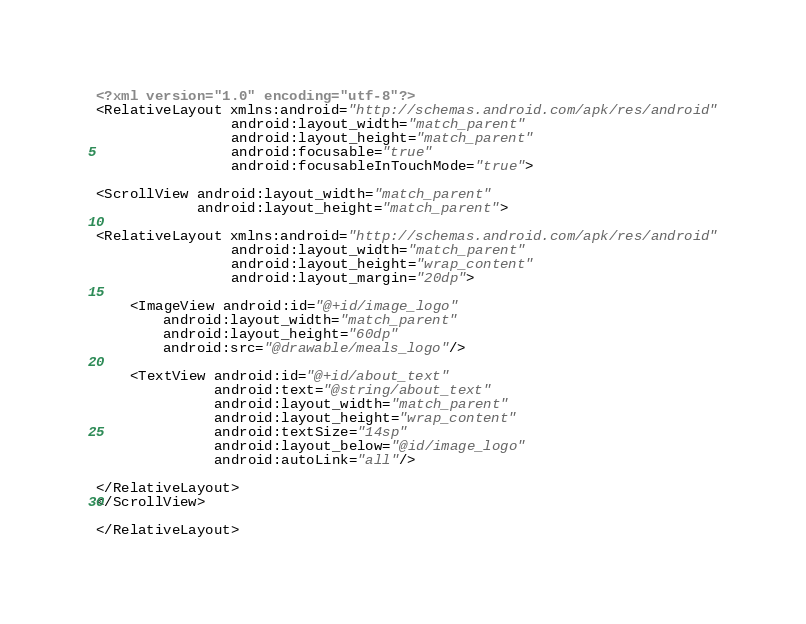<code> <loc_0><loc_0><loc_500><loc_500><_XML_><?xml version="1.0" encoding="utf-8"?>
<RelativeLayout xmlns:android="http://schemas.android.com/apk/res/android"
                android:layout_width="match_parent"
                android:layout_height="match_parent"
                android:focusable="true"
                android:focusableInTouchMode="true">

<ScrollView android:layout_width="match_parent"
            android:layout_height="match_parent">

<RelativeLayout xmlns:android="http://schemas.android.com/apk/res/android"
                android:layout_width="match_parent"
                android:layout_height="wrap_content"
                android:layout_margin="20dp">

    <ImageView android:id="@+id/image_logo"
        android:layout_width="match_parent"
        android:layout_height="60dp"
        android:src="@drawable/meals_logo"/>

    <TextView android:id="@+id/about_text"
              android:text="@string/about_text"
              android:layout_width="match_parent"
              android:layout_height="wrap_content"
              android:textSize="14sp"
              android:layout_below="@id/image_logo"
              android:autoLink="all"/>

</RelativeLayout>
</ScrollView>

</RelativeLayout>
</code> 